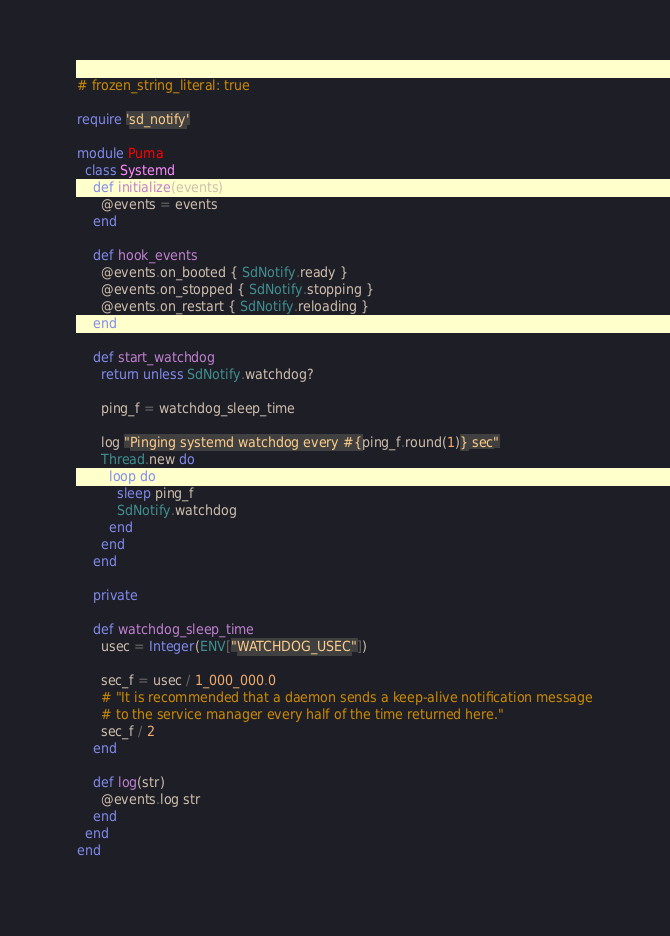Convert code to text. <code><loc_0><loc_0><loc_500><loc_500><_Ruby_># frozen_string_literal: true

require 'sd_notify'

module Puma
  class Systemd
    def initialize(events)
      @events = events
    end

    def hook_events
      @events.on_booted { SdNotify.ready }
      @events.on_stopped { SdNotify.stopping }
      @events.on_restart { SdNotify.reloading }
    end

    def start_watchdog
      return unless SdNotify.watchdog?

      ping_f = watchdog_sleep_time

      log "Pinging systemd watchdog every #{ping_f.round(1)} sec"
      Thread.new do
        loop do
          sleep ping_f
          SdNotify.watchdog
        end
      end
    end

    private

    def watchdog_sleep_time
      usec = Integer(ENV["WATCHDOG_USEC"])

      sec_f = usec / 1_000_000.0
      # "It is recommended that a daemon sends a keep-alive notification message
      # to the service manager every half of the time returned here."
      sec_f / 2
    end

    def log(str)
      @events.log str
    end
  end
end
</code> 